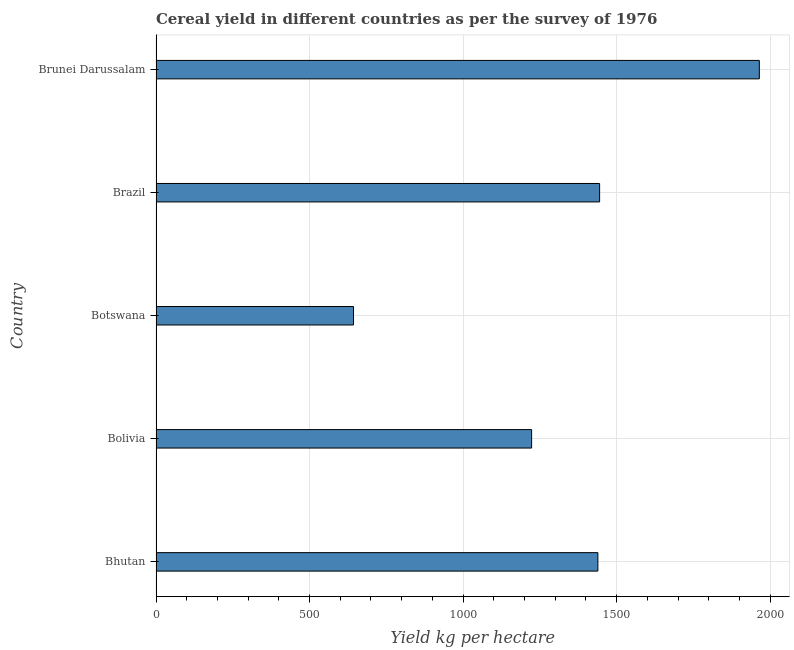Does the graph contain any zero values?
Your response must be concise. No. Does the graph contain grids?
Offer a very short reply. Yes. What is the title of the graph?
Ensure brevity in your answer.  Cereal yield in different countries as per the survey of 1976. What is the label or title of the X-axis?
Provide a short and direct response. Yield kg per hectare. What is the cereal yield in Brunei Darussalam?
Your answer should be very brief. 1964.67. Across all countries, what is the maximum cereal yield?
Ensure brevity in your answer.  1964.67. Across all countries, what is the minimum cereal yield?
Provide a succinct answer. 643.17. In which country was the cereal yield maximum?
Your answer should be very brief. Brunei Darussalam. In which country was the cereal yield minimum?
Provide a short and direct response. Botswana. What is the sum of the cereal yield?
Provide a short and direct response. 6714.38. What is the difference between the cereal yield in Bolivia and Brazil?
Offer a very short reply. -221.46. What is the average cereal yield per country?
Offer a terse response. 1342.88. What is the median cereal yield?
Provide a short and direct response. 1438.88. What is the ratio of the cereal yield in Botswana to that in Brazil?
Your response must be concise. 0.45. What is the difference between the highest and the second highest cereal yield?
Keep it short and to the point. 520.11. What is the difference between the highest and the lowest cereal yield?
Provide a succinct answer. 1321.51. What is the difference between two consecutive major ticks on the X-axis?
Keep it short and to the point. 500. What is the Yield kg per hectare in Bhutan?
Your response must be concise. 1438.88. What is the Yield kg per hectare of Bolivia?
Offer a terse response. 1223.1. What is the Yield kg per hectare of Botswana?
Make the answer very short. 643.17. What is the Yield kg per hectare in Brazil?
Offer a terse response. 1444.56. What is the Yield kg per hectare of Brunei Darussalam?
Keep it short and to the point. 1964.67. What is the difference between the Yield kg per hectare in Bhutan and Bolivia?
Give a very brief answer. 215.78. What is the difference between the Yield kg per hectare in Bhutan and Botswana?
Provide a short and direct response. 795.71. What is the difference between the Yield kg per hectare in Bhutan and Brazil?
Keep it short and to the point. -5.69. What is the difference between the Yield kg per hectare in Bhutan and Brunei Darussalam?
Your response must be concise. -525.8. What is the difference between the Yield kg per hectare in Bolivia and Botswana?
Offer a terse response. 579.93. What is the difference between the Yield kg per hectare in Bolivia and Brazil?
Provide a short and direct response. -221.46. What is the difference between the Yield kg per hectare in Bolivia and Brunei Darussalam?
Make the answer very short. -741.57. What is the difference between the Yield kg per hectare in Botswana and Brazil?
Your answer should be compact. -801.4. What is the difference between the Yield kg per hectare in Botswana and Brunei Darussalam?
Offer a very short reply. -1321.51. What is the difference between the Yield kg per hectare in Brazil and Brunei Darussalam?
Your answer should be compact. -520.11. What is the ratio of the Yield kg per hectare in Bhutan to that in Bolivia?
Keep it short and to the point. 1.18. What is the ratio of the Yield kg per hectare in Bhutan to that in Botswana?
Ensure brevity in your answer.  2.24. What is the ratio of the Yield kg per hectare in Bhutan to that in Brunei Darussalam?
Give a very brief answer. 0.73. What is the ratio of the Yield kg per hectare in Bolivia to that in Botswana?
Your response must be concise. 1.9. What is the ratio of the Yield kg per hectare in Bolivia to that in Brazil?
Offer a very short reply. 0.85. What is the ratio of the Yield kg per hectare in Bolivia to that in Brunei Darussalam?
Provide a short and direct response. 0.62. What is the ratio of the Yield kg per hectare in Botswana to that in Brazil?
Give a very brief answer. 0.45. What is the ratio of the Yield kg per hectare in Botswana to that in Brunei Darussalam?
Your answer should be very brief. 0.33. What is the ratio of the Yield kg per hectare in Brazil to that in Brunei Darussalam?
Ensure brevity in your answer.  0.73. 